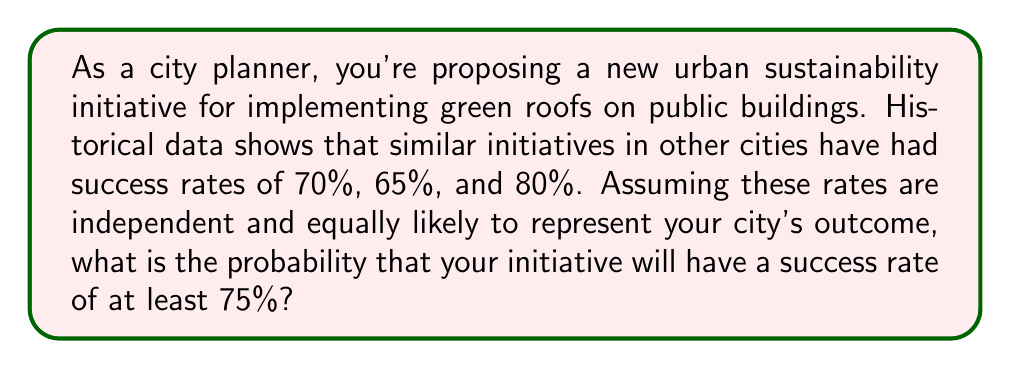What is the answer to this math problem? Let's approach this step-by-step:

1) First, we need to define our random variable. Let $X$ be the success rate of the initiative.

2) Given the historical data, we can assume that $X$ follows a discrete uniform distribution with three possible outcomes:
   $X \in \{0.70, 0.65, 0.80\}$

3) Each outcome has an equal probability of $\frac{1}{3}$.

4) We want to find $P(X \geq 0.75)$, which is the probability that the success rate is at least 75%.

5) We can calculate this by summing the probabilities of all outcomes that meet this criterion:

   $P(X \geq 0.75) = P(X = 0.80)$

   This is because 0.80 is the only value in our set that is greater than or equal to 0.75.

6) Since the probability of each outcome is $\frac{1}{3}$:

   $P(X \geq 0.75) = P(X = 0.80) = \frac{1}{3}$

Therefore, the probability that your initiative will have a success rate of at least 75% is $\frac{1}{3}$ or approximately 0.3333 or 33.33%.
Answer: $\frac{1}{3}$ 